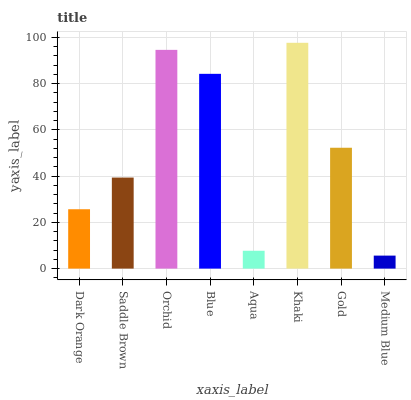Is Medium Blue the minimum?
Answer yes or no. Yes. Is Khaki the maximum?
Answer yes or no. Yes. Is Saddle Brown the minimum?
Answer yes or no. No. Is Saddle Brown the maximum?
Answer yes or no. No. Is Saddle Brown greater than Dark Orange?
Answer yes or no. Yes. Is Dark Orange less than Saddle Brown?
Answer yes or no. Yes. Is Dark Orange greater than Saddle Brown?
Answer yes or no. No. Is Saddle Brown less than Dark Orange?
Answer yes or no. No. Is Gold the high median?
Answer yes or no. Yes. Is Saddle Brown the low median?
Answer yes or no. Yes. Is Dark Orange the high median?
Answer yes or no. No. Is Gold the low median?
Answer yes or no. No. 